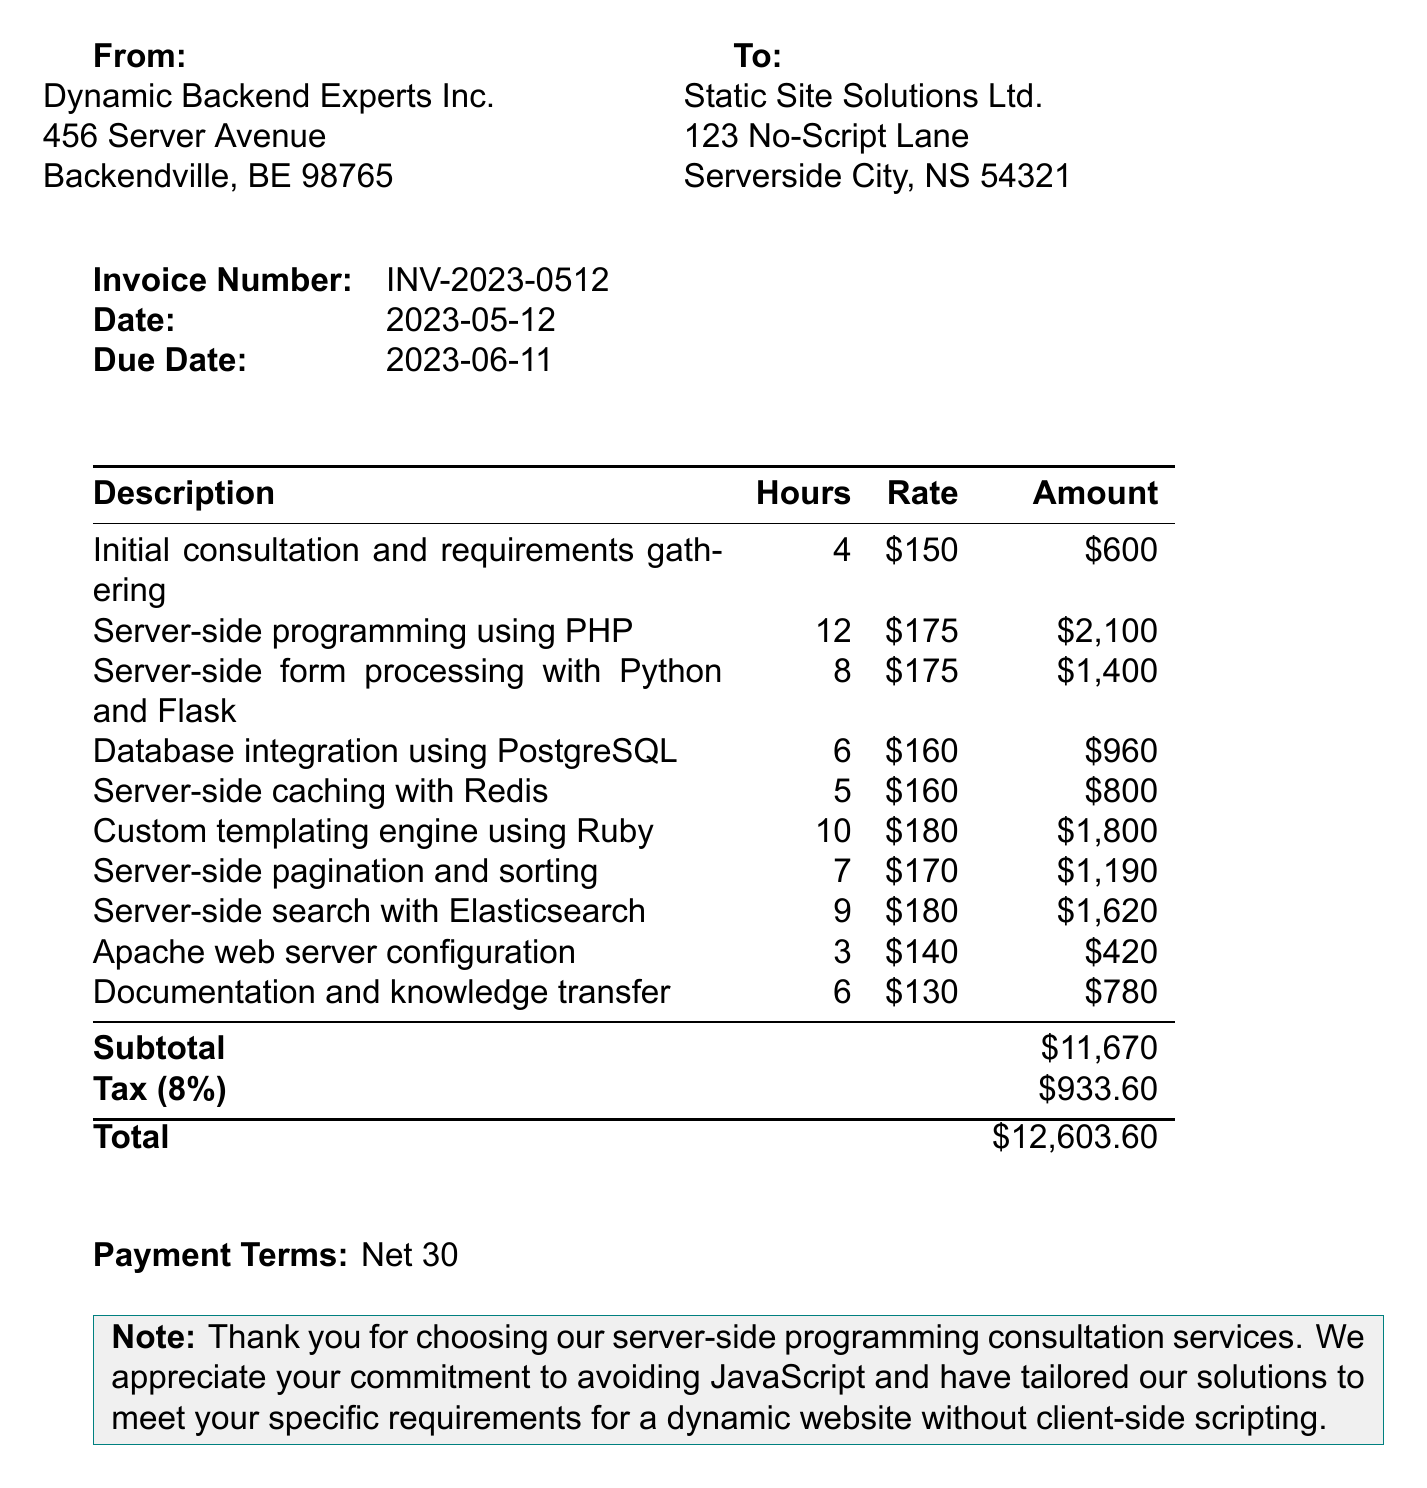What is the invoice number? The invoice number is a unique identifier for this invoice document.
Answer: INV-2023-0512 What is the due date for the invoice? The due date indicates when the payment is required, specified in the document.
Answer: 2023-06-11 Who is the client? The client name is listed in the invoice, identifying the company receiving the services.
Answer: Static Site Solutions Ltd What is the total amount due? The total amount is the final charge that combines the subtotal and tax.
Answer: 12603.60 How many hours were billed for server-side form processing? The invoice includes a breakdown of hours spent on each service item.
Answer: 8 What programming language was used for server-side caching? Each line item specifies the technology used for the respective service.
Answer: Redis What is the payment term specified in the document? Payment terms indicate how long the client has to settle the invoice.
Answer: Net 30 What service involved the development of a custom templating engine? The document lists all services provided, including the specific task of creating a templating engine.
Answer: Ruby What percentage is the tax rate? The tax rate applies to the subtotal, specified in the invoice for calculating tax.
Answer: 8% 